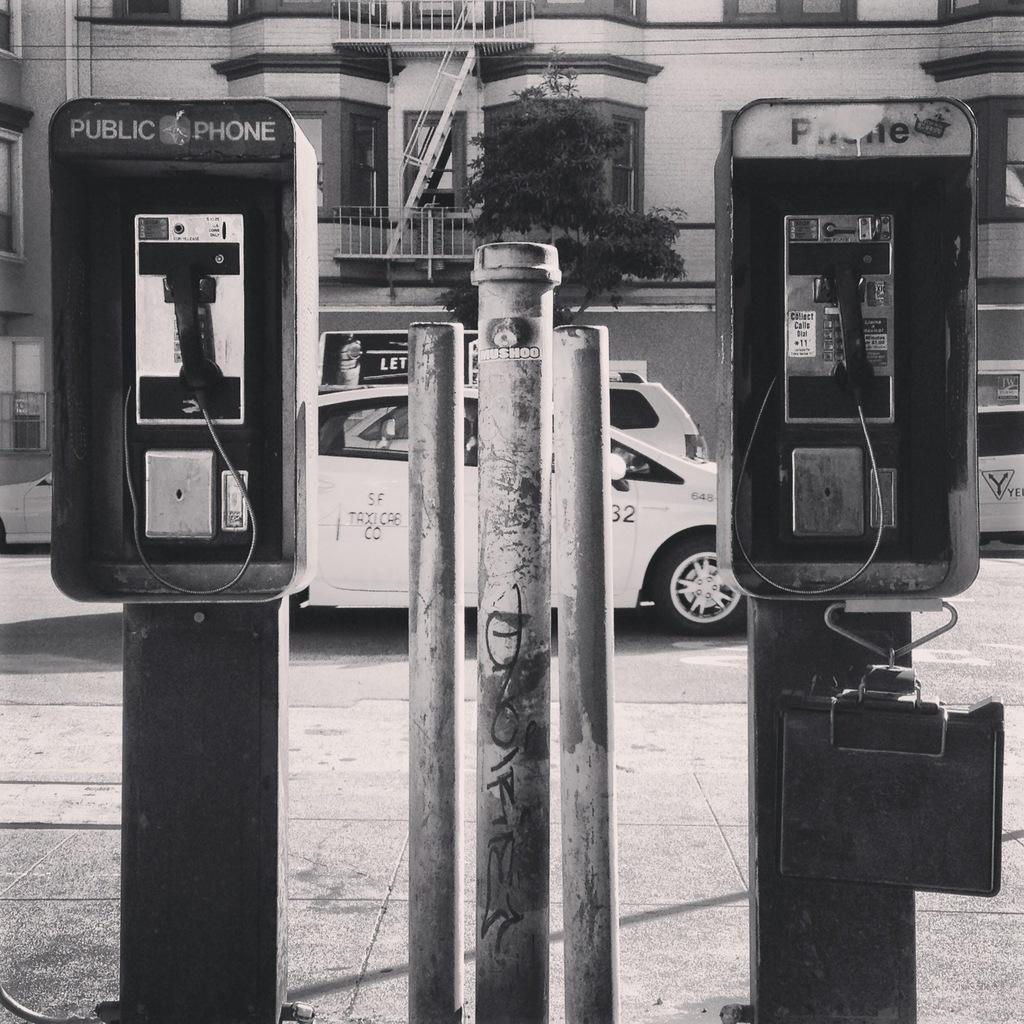What is the color scheme of the image? The image is black and white. What type of object can be seen in the image? There are public phones in the image. What is located in the middle of the image? There is a pole in the middle of the image. What can be seen in the background of the image? Cars, buildings, and trees are visible in the background. What type of machine is used for distributing goods in the image? There is no machine for distributing goods present in the image. What type of road is visible in the image? The image does not show a specific type of road; it only shows cars on a road in the background. 